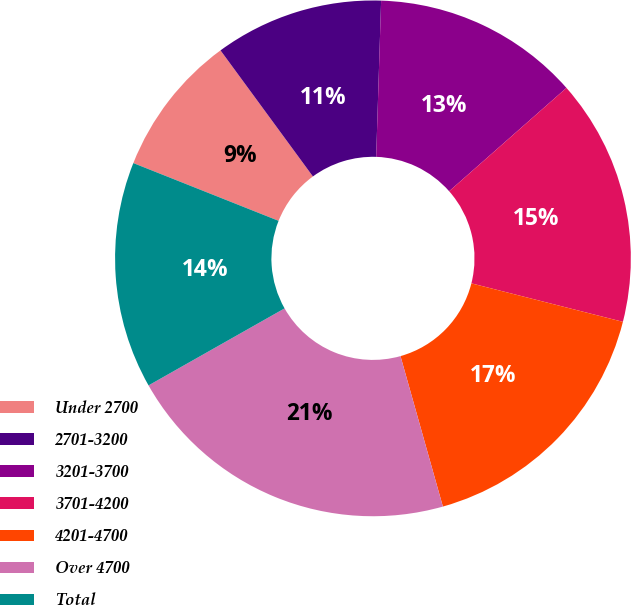Convert chart to OTSL. <chart><loc_0><loc_0><loc_500><loc_500><pie_chart><fcel>Under 2700<fcel>2701-3200<fcel>3201-3700<fcel>3701-4200<fcel>4201-4700<fcel>Over 4700<fcel>Total<nl><fcel>8.91%<fcel>10.57%<fcel>13.0%<fcel>15.45%<fcel>16.67%<fcel>21.17%<fcel>14.22%<nl></chart> 